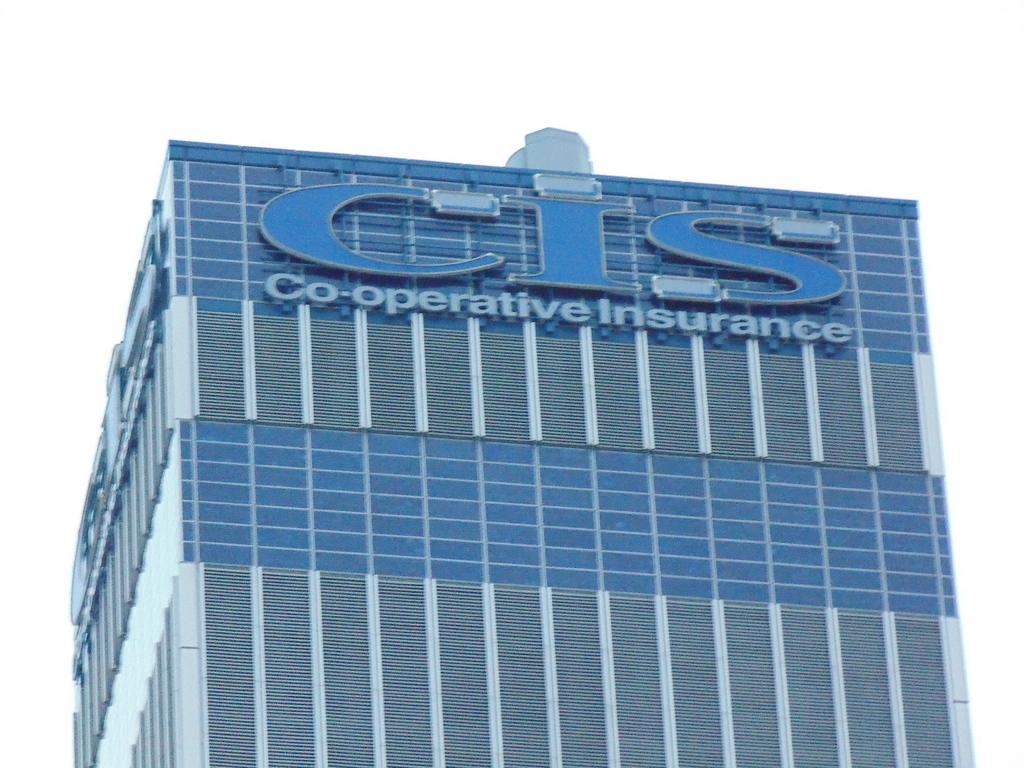Can you describe this image briefly? In this image I can see a building in gray and blue color and I can see white color background. 